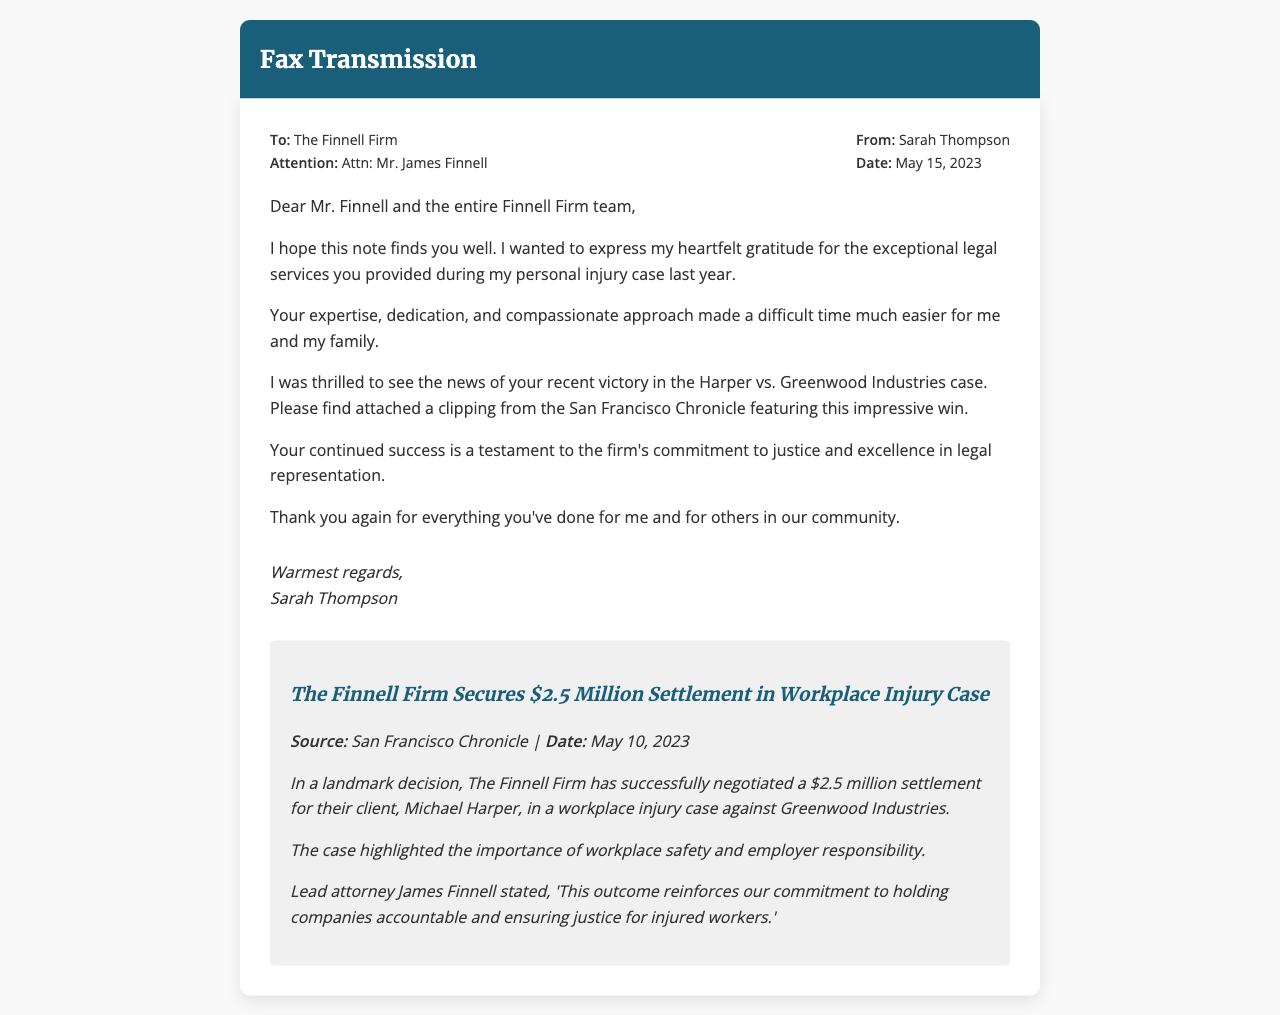What is the name of the sender? The sender of the fax is identified in the "From:" section, which states Sarah Thompson.
Answer: Sarah Thompson What is the date of the fax? The date is mentioned in the "Date:" section as May 15, 2023.
Answer: May 15, 2023 Who is the attention of the fax addressed to? The "Attention:" section specifies that the fax is directed to Mr. James Finnell.
Answer: Mr. James Finnell What was the settlement amount in the Harper vs. Greenwood Industries case? The newspaper clipping states the settlement amount as $2.5 million.
Answer: $2.5 million Which newspaper featured the article about the legal victory? The document mentions the San Francisco Chronicle as the source of the article.
Answer: San Francisco Chronicle What was the main legal focus of the case mentioned in the newspaper clipping? The case highlighted workplace safety, as noted in the article's summary.
Answer: Workplace safety What is the closing phrase used by Sarah Thompson? The closing phrase is captured in the signature section, which states "Warmest regards."
Answer: Warmest regards What is the title of the article in the newspaper clipping? The title of the article is specified at the beginning of the clipping as "The Finnell Firm Secures $2.5 Million Settlement in Workplace Injury Case."
Answer: The Finnell Firm Secures $2.5 Million Settlement in Workplace Injury Case 